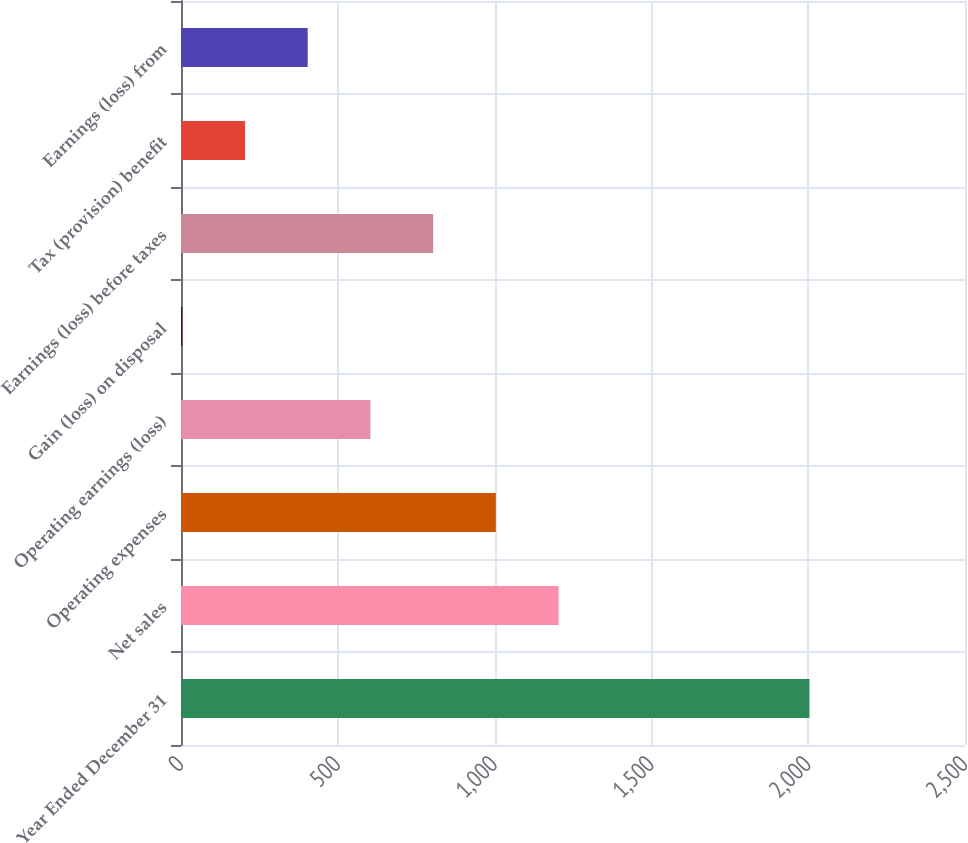Convert chart to OTSL. <chart><loc_0><loc_0><loc_500><loc_500><bar_chart><fcel>Year Ended December 31<fcel>Net sales<fcel>Operating expenses<fcel>Operating earnings (loss)<fcel>Gain (loss) on disposal<fcel>Earnings (loss) before taxes<fcel>Tax (provision) benefit<fcel>Earnings (loss) from<nl><fcel>2004<fcel>1204<fcel>1004<fcel>604<fcel>4<fcel>804<fcel>204<fcel>404<nl></chart> 